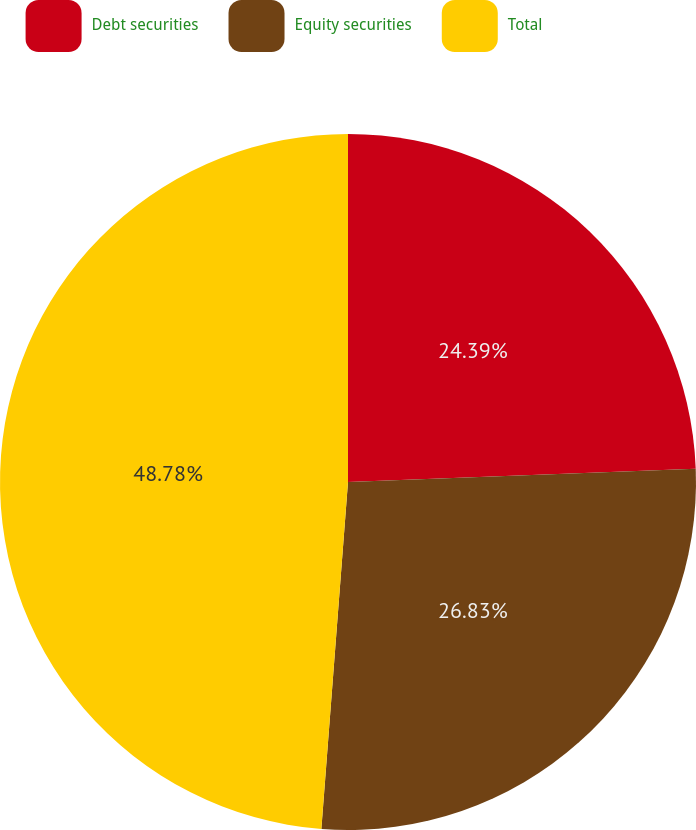Convert chart to OTSL. <chart><loc_0><loc_0><loc_500><loc_500><pie_chart><fcel>Debt securities<fcel>Equity securities<fcel>Total<nl><fcel>24.39%<fcel>26.83%<fcel>48.78%<nl></chart> 